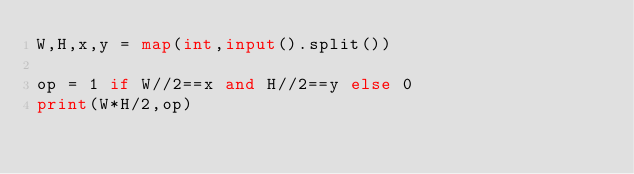<code> <loc_0><loc_0><loc_500><loc_500><_Python_>W,H,x,y = map(int,input().split())

op = 1 if W//2==x and H//2==y else 0
print(W*H/2,op)</code> 